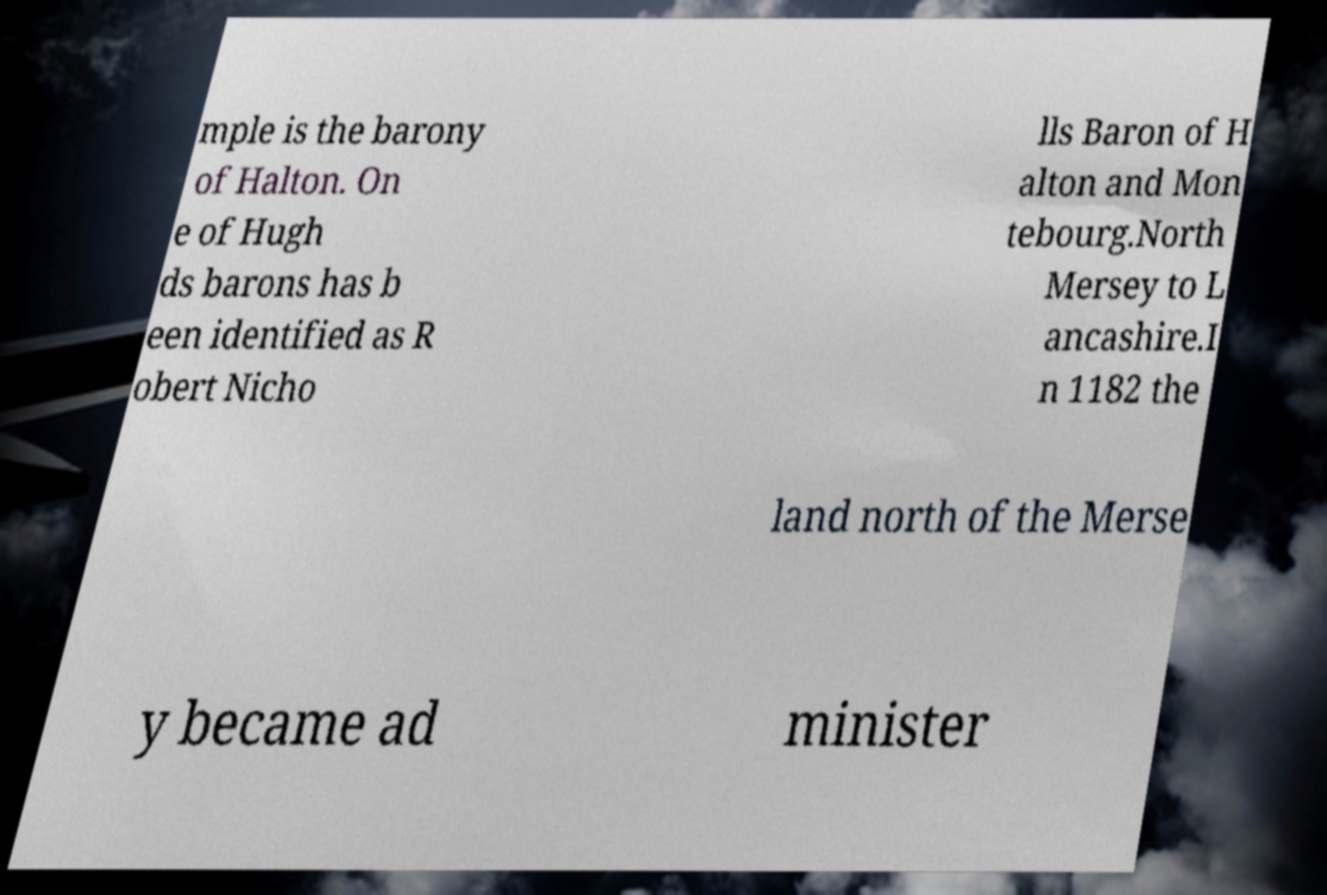Please read and relay the text visible in this image. What does it say? mple is the barony of Halton. On e of Hugh ds barons has b een identified as R obert Nicho lls Baron of H alton and Mon tebourg.North Mersey to L ancashire.I n 1182 the land north of the Merse y became ad minister 